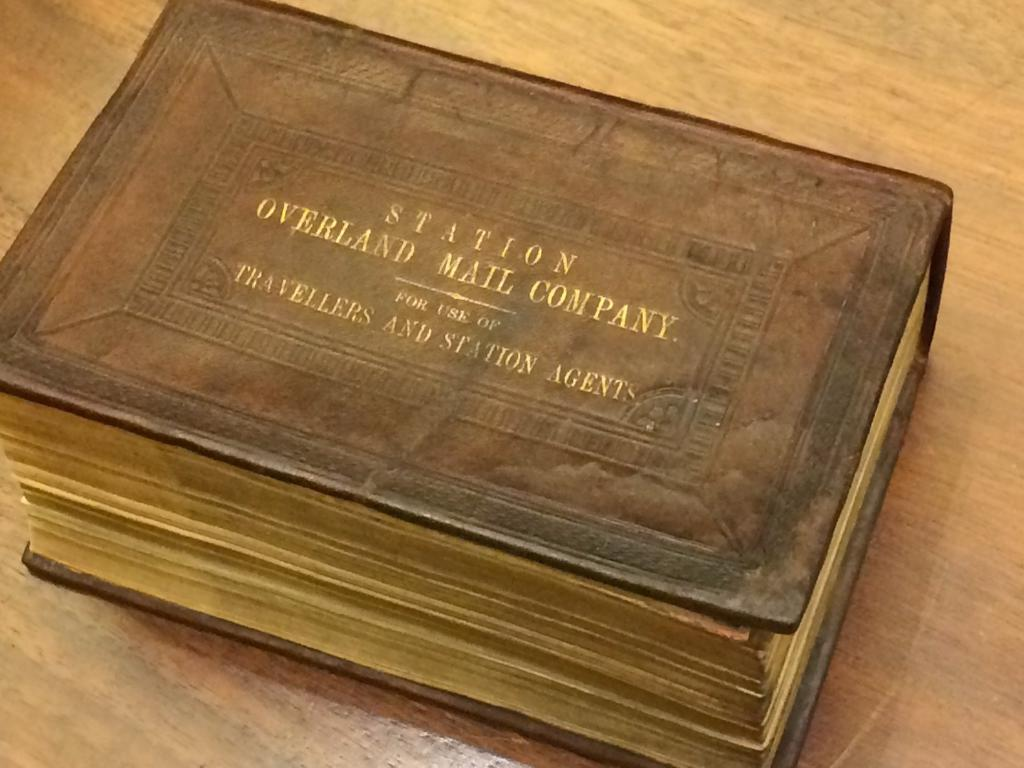What object is visible in the image? There is a book in the image. What can be found inside the book? There are words written in the book. On what surface is the book placed? The book is on a brown color surface. What type of society is depicted in the image? There is no society depicted in the image; it only shows a book with words on a brown color surface. 